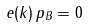<formula> <loc_0><loc_0><loc_500><loc_500>e ( k ) \, p _ { B } = 0</formula> 